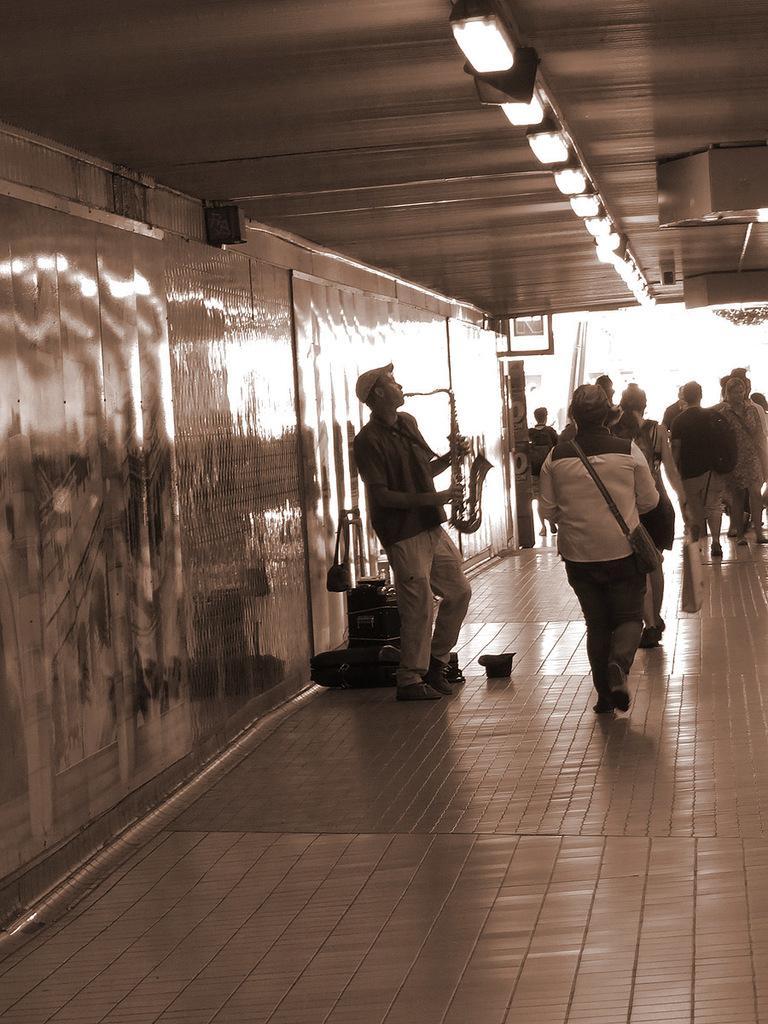Could you give a brief overview of what you see in this image? In this image I can see the group of people with the dresses. I can see few people with the bags and there is a person holding the trumpet. There are some objects on the floor. To the left I can see the wall and there are lights in the top. 